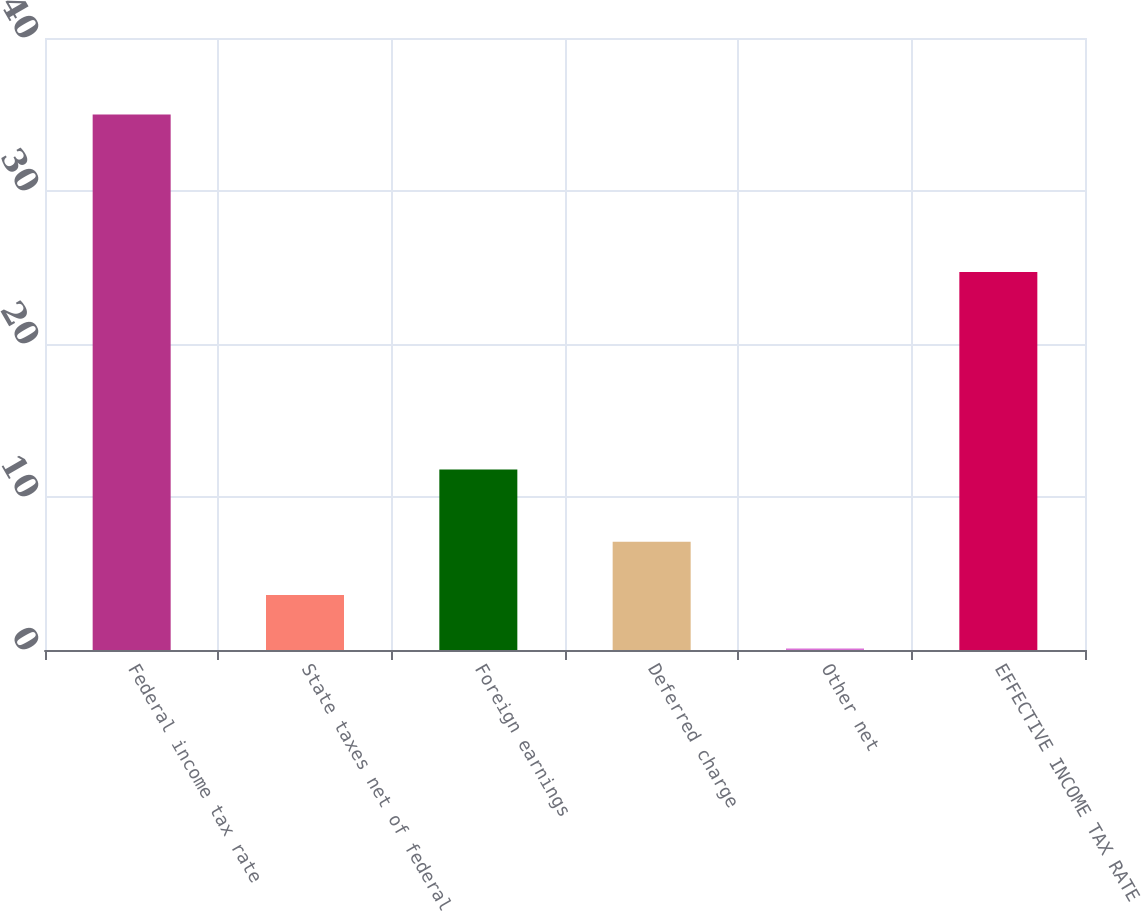<chart> <loc_0><loc_0><loc_500><loc_500><bar_chart><fcel>Federal income tax rate<fcel>State taxes net of federal<fcel>Foreign earnings<fcel>Deferred charge<fcel>Other net<fcel>EFFECTIVE INCOME TAX RATE<nl><fcel>35<fcel>3.59<fcel>11.8<fcel>7.08<fcel>0.1<fcel>24.7<nl></chart> 